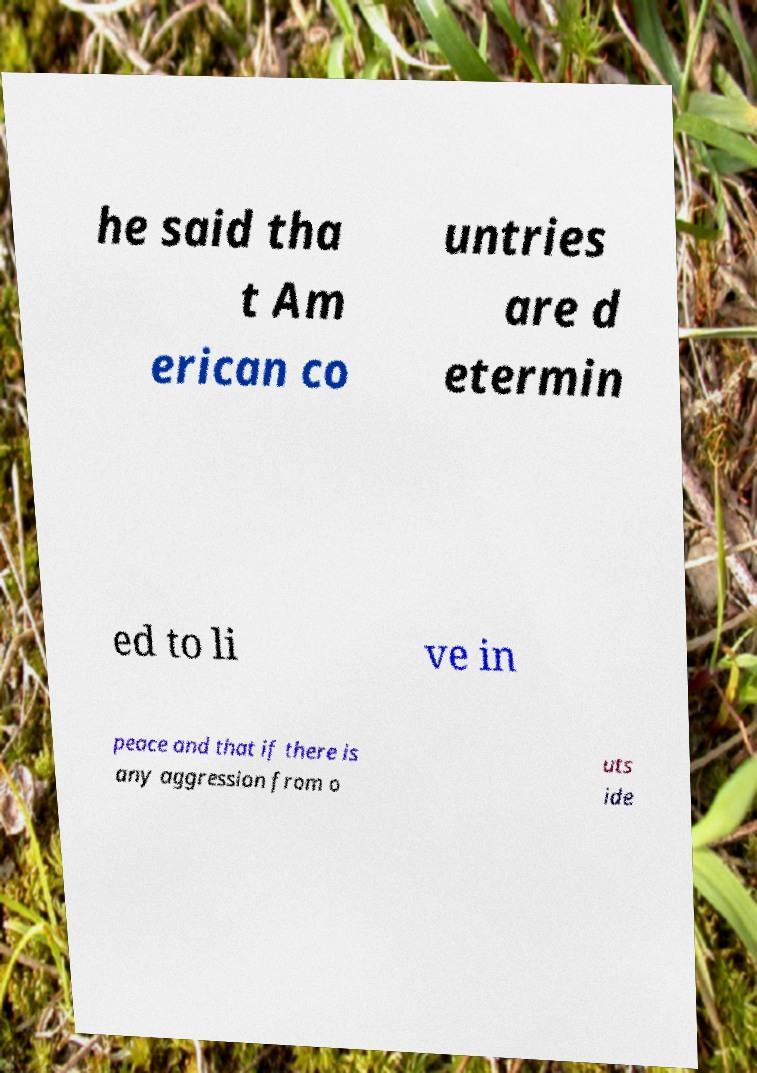For documentation purposes, I need the text within this image transcribed. Could you provide that? he said tha t Am erican co untries are d etermin ed to li ve in peace and that if there is any aggression from o uts ide 